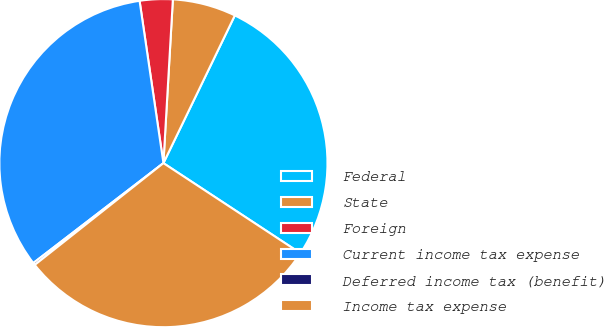Convert chart to OTSL. <chart><loc_0><loc_0><loc_500><loc_500><pie_chart><fcel>Federal<fcel>State<fcel>Foreign<fcel>Current income tax expense<fcel>Deferred income tax (benefit)<fcel>Income tax expense<nl><fcel>27.09%<fcel>6.25%<fcel>3.24%<fcel>33.1%<fcel>0.23%<fcel>30.09%<nl></chart> 